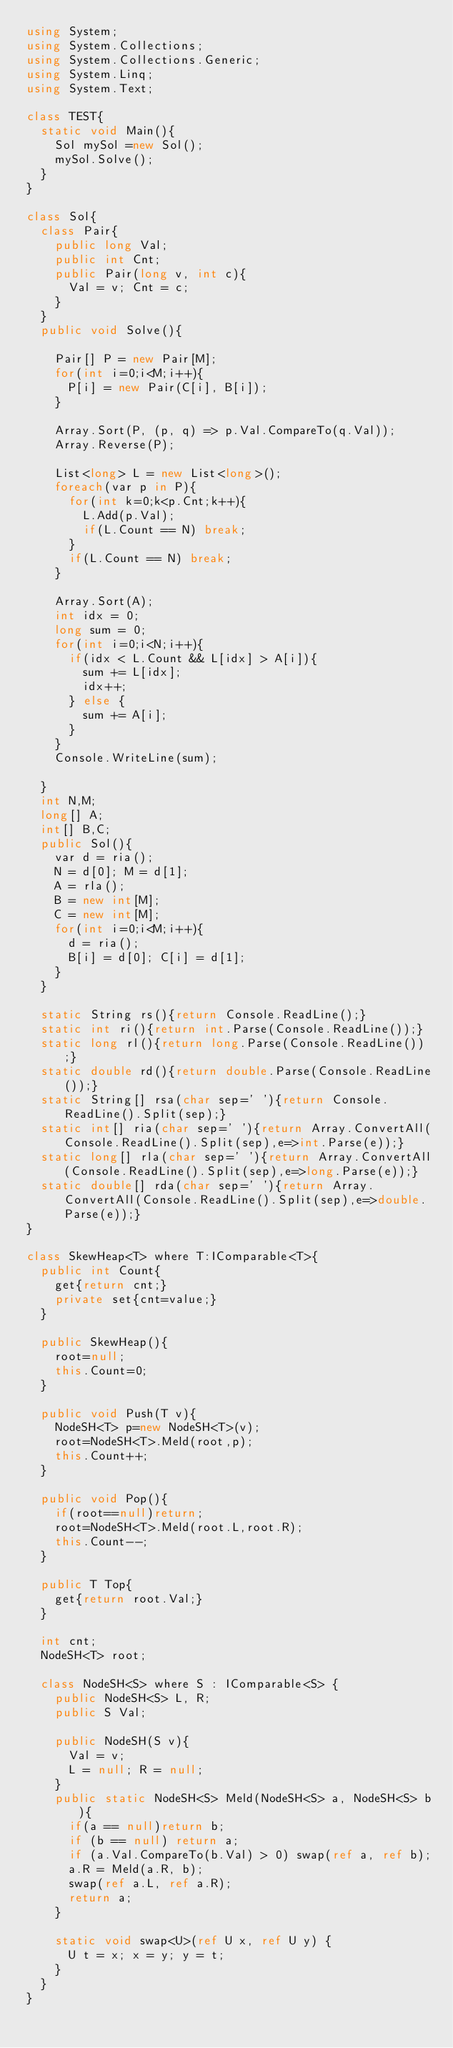<code> <loc_0><loc_0><loc_500><loc_500><_C#_>using System;
using System.Collections;
using System.Collections.Generic;
using System.Linq;
using System.Text;

class TEST{
	static void Main(){
		Sol mySol =new Sol();
		mySol.Solve();
	}
}

class Sol{
	class Pair{
		public long Val;
		public int Cnt;
		public Pair(long v, int c){
			Val = v; Cnt = c;
		}
	}
	public void Solve(){
		
		Pair[] P = new Pair[M];
		for(int i=0;i<M;i++){
			P[i] = new Pair(C[i], B[i]);
		}
		
		Array.Sort(P, (p, q) => p.Val.CompareTo(q.Val));
		Array.Reverse(P);
		
		List<long> L = new List<long>();
		foreach(var p in P){
			for(int k=0;k<p.Cnt;k++){
				L.Add(p.Val);
				if(L.Count == N) break;
			}
			if(L.Count == N) break;
		}
		
		Array.Sort(A);
		int idx = 0;
		long sum = 0;
		for(int i=0;i<N;i++){
			if(idx < L.Count && L[idx] > A[i]){
				sum += L[idx];
				idx++;
			} else {
				sum += A[i];
			}
		}
		Console.WriteLine(sum);
		
	}
	int N,M;
	long[] A;
	int[] B,C;
	public Sol(){
		var d = ria();
		N = d[0]; M = d[1];
		A = rla();
		B = new int[M];
		C = new int[M];
		for(int i=0;i<M;i++){
			d = ria();
			B[i] = d[0]; C[i] = d[1];
		}
	}

	static String rs(){return Console.ReadLine();}
	static int ri(){return int.Parse(Console.ReadLine());}
	static long rl(){return long.Parse(Console.ReadLine());}
	static double rd(){return double.Parse(Console.ReadLine());}
	static String[] rsa(char sep=' '){return Console.ReadLine().Split(sep);}
	static int[] ria(char sep=' '){return Array.ConvertAll(Console.ReadLine().Split(sep),e=>int.Parse(e));}
	static long[] rla(char sep=' '){return Array.ConvertAll(Console.ReadLine().Split(sep),e=>long.Parse(e));}
	static double[] rda(char sep=' '){return Array.ConvertAll(Console.ReadLine().Split(sep),e=>double.Parse(e));}
}

class SkewHeap<T> where T:IComparable<T>{
	public int Count{
		get{return cnt;}
		private set{cnt=value;}
	}
	
	public SkewHeap(){
		root=null;
		this.Count=0;
	}
	
	public void Push(T v){
		NodeSH<T> p=new NodeSH<T>(v);
		root=NodeSH<T>.Meld(root,p);
		this.Count++;
	}
	
	public void Pop(){
		if(root==null)return;
		root=NodeSH<T>.Meld(root.L,root.R);
		this.Count--;
	}
	
	public T Top{
		get{return root.Val;}
	}
	
	int cnt;
	NodeSH<T> root;
	
	class NodeSH<S> where S : IComparable<S> {
		public NodeSH<S> L, R;
		public S Val;

		public NodeSH(S v){
			Val = v;
			L = null; R = null;
		}
		public static NodeSH<S> Meld(NodeSH<S> a, NodeSH<S> b){
			if(a == null)return b;
			if (b == null) return a;
			if (a.Val.CompareTo(b.Val) > 0) swap(ref a, ref b);
			a.R = Meld(a.R, b);
			swap(ref a.L, ref a.R);
			return a;
		}

		static void swap<U>(ref U x, ref U y) {
			U t = x; x = y; y = t;
		}
	}
}
</code> 